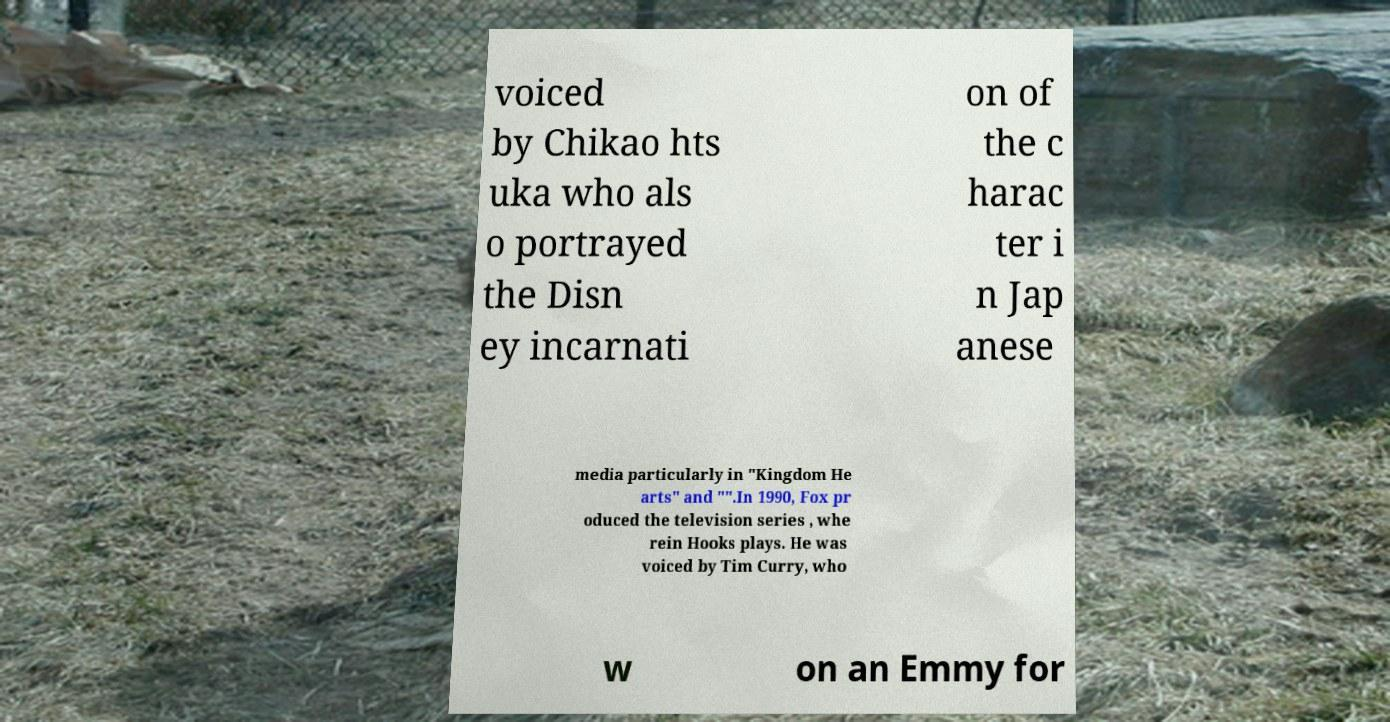I need the written content from this picture converted into text. Can you do that? voiced by Chikao hts uka who als o portrayed the Disn ey incarnati on of the c harac ter i n Jap anese media particularly in "Kingdom He arts" and "".In 1990, Fox pr oduced the television series , whe rein Hooks plays. He was voiced by Tim Curry, who w on an Emmy for 